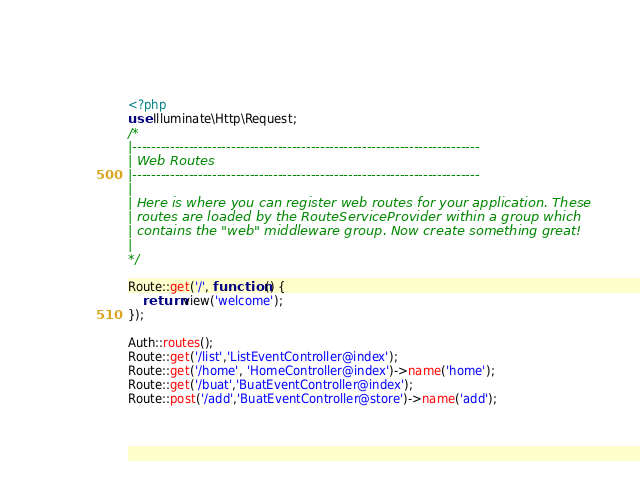Convert code to text. <code><loc_0><loc_0><loc_500><loc_500><_PHP_><?php
use Illuminate\Http\Request;
/*
|--------------------------------------------------------------------------
| Web Routes
|--------------------------------------------------------------------------
|
| Here is where you can register web routes for your application. These
| routes are loaded by the RouteServiceProvider within a group which
| contains the "web" middleware group. Now create something great!
|
*/

Route::get('/', function () {
    return view('welcome');
});

Auth::routes();
Route::get('/list','ListEventController@index');
Route::get('/home', 'HomeController@index')->name('home');
Route::get('/buat','BuatEventController@index');
Route::post('/add','BuatEventController@store')->name('add');</code> 